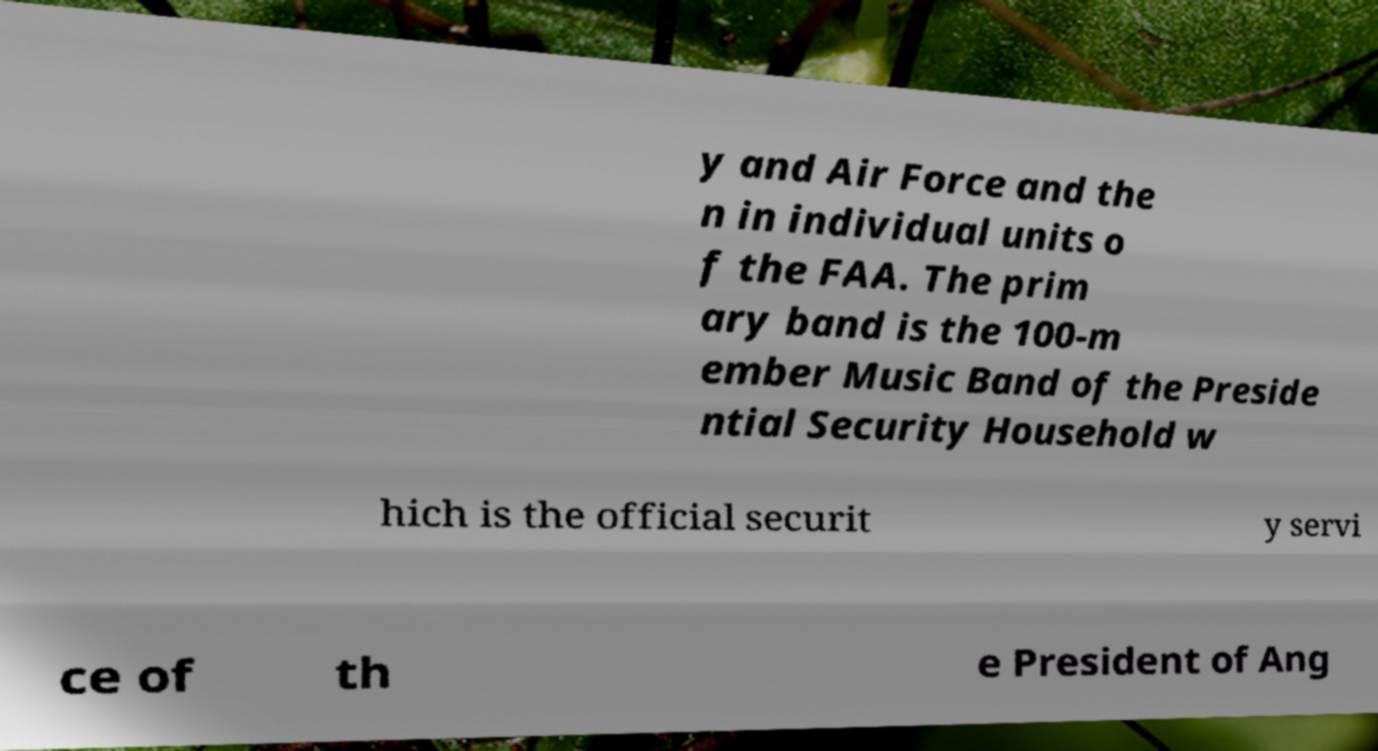Could you assist in decoding the text presented in this image and type it out clearly? y and Air Force and the n in individual units o f the FAA. The prim ary band is the 100-m ember Music Band of the Preside ntial Security Household w hich is the official securit y servi ce of th e President of Ang 